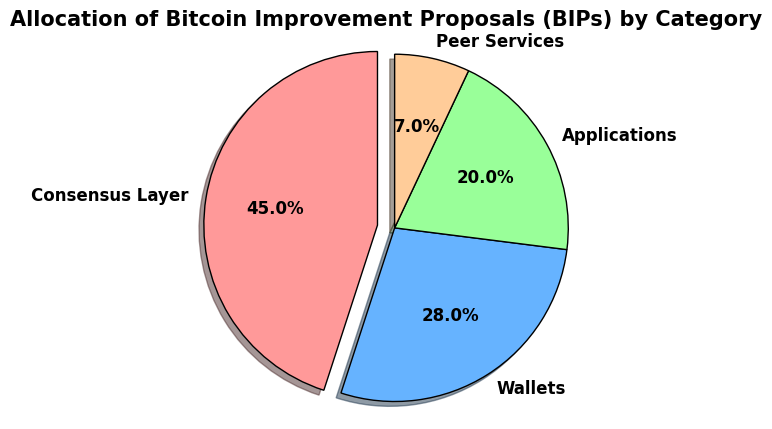what category has the highest percentage of Bitcoin Improvement Proposals (BIPs)? The pie chart indicates the portions allocated to each category. The "Consensus Layer" occupies the largest section, which is slightly displaced outward from the center. It also displays the highest percentage of 45.
Answer: Consensus Layer what's the combined percentage of Wallets and Applications categories? The percentages for Wallets and Applications are 28% and 20%, respectively. Adding them together gives 28% + 20% = 48%.
Answer: 48% is the number of BIPs in the Peer Services category greater than or less than that in the Wallets category? The count for Peer Services is 7, while the Wallets category has 28 BIPs. Therefore, Peer Services has fewer BIPs compared to Wallets.
Answer: Less than how much larger is the Consensus Layer category compared to the Peer Services category, in terms of the number of BIPs? The Consensus Layer has 45 BIPs and Peer Services has 7 BIPs. Subtracting the two gives 45 - 7 = 38 BIPs larger.
Answer: 38 BIPs what percentage of BIPs does the smallest category represent, and which category is it? The smallest category by percentage is Peer Services, which has 7%.
Answer: 7%, Peer Services which category is depicted in blue, and what percentage does it represent? From the pie chart, the segment colored blue represents Wallets, which accounts for 28% of the total BIPs.
Answer: Wallets, 28% rank the categories from highest to lowest by their BIP counts. Based on the pie chart, the categories can be ranked as follows: Consensus Layer (45 BIPs), Wallets (28 BIPs), Applications (20 BIPs), Peer Services (7 BIPs).
Answer: Consensus Layer > Wallets > Applications > Peer Services what is the average number of BIPs per category? There are four categories: Consensus Layer (45), Wallets (28), Applications (20), and Peer Services (7). Summing these gives 45 + 28 + 20 + 7 = 100 BIPs. Dividing this by 4, the average number of BIPs per category is 100 / 4 = 25.
Answer: 25 if the number of BIPs for the Applications category increased by 15, how would that change its percentage? Currently, Applications has 20 BIPs. Adding 15 increases it to 35 BIPs. Total now becomes 115 BIPs. The new percentage for Applications would be (35 / 115) * 100 which approximates to 30.4%.
Answer: 30.4% 